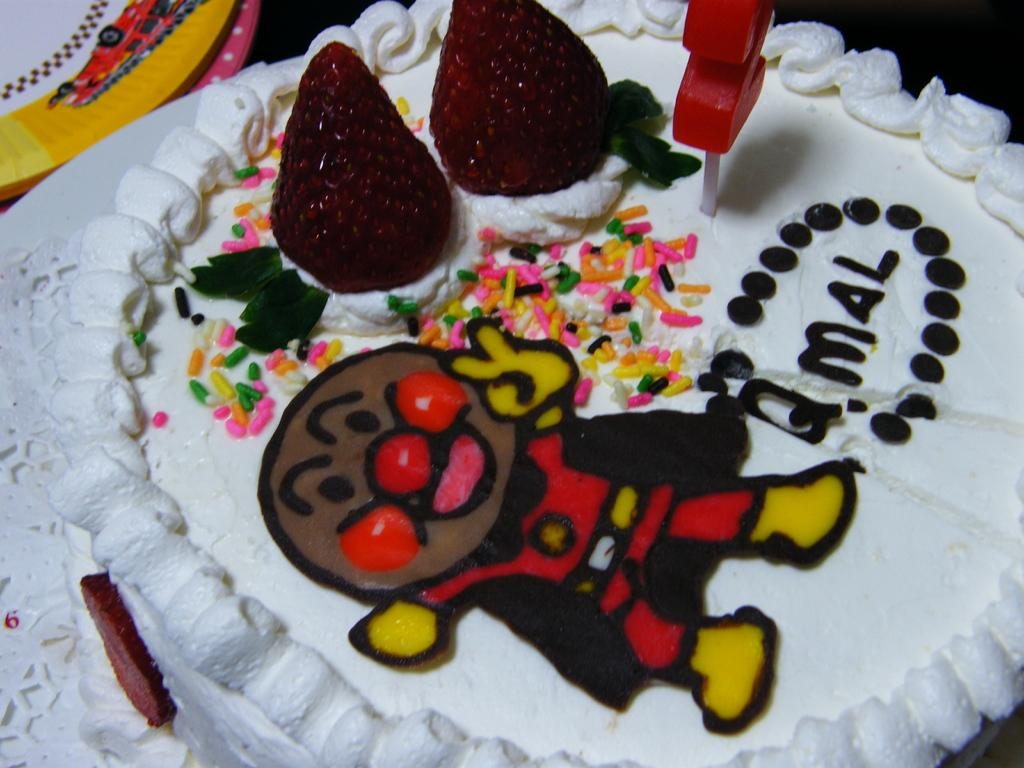What is the main subject of the image? There is a cake in the image. What is a notable feature of the cake? The cake contains cherries. Is there any other detail on the cake? Yes, there is a depiction of a person on the cake. What type of brass instrument is being played by the person depicted on the cake? There is no brass instrument or person playing an instrument depicted on the cake; it only features a person's image. 